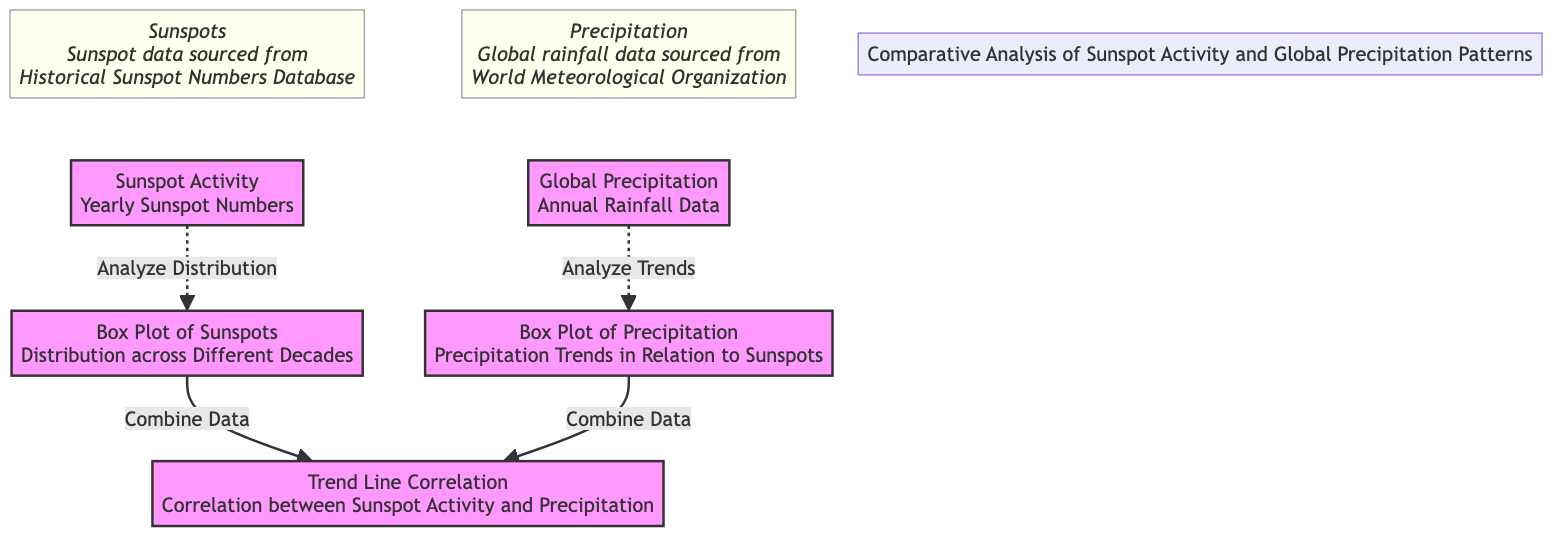What is the main subject of the diagram? The diagram focuses on the comparative analysis of sunspot activity and global precipitation patterns. It illustrates how sunspot activity relates to global rainfall trends over the years.
Answer: Comparative analysis of sunspot activity and global precipitation patterns How many main components are there in the diagram? The diagram consists of five main components: sunspot activity, global precipitation, box plot of sunspots, box plot of precipitation, and trend line correlation.
Answer: Five What is the relationship indicated between the box plots and trend line correlation? The box plots of both sunspot activity and global precipitation serve as inputs for the trend line correlation, implying that the correlation is derived from the data represented in both box plots.
Answer: Combine Data Which node provides the source for sunspot data? The diagram indicates that the sunspot data is sourced from the Historical Sunspot Numbers Database. This information is provided as an annotation associated with the sunspot activity node.
Answer: Historical Sunspot Numbers Database Why is global rainfall data sourced from the World Meteorological Organization? The World Meteorological Organization is a reliable and authoritative source for global precipitation data, providing consistent and standardized information crucial for analyzing precipitation trends in relation to sunspots.
Answer: Reliable source How does the trend line correlation connect to both box plots? The trend line correlation draws connections from both the box plot of sunspots and the box plot of precipitation, indicating that the final analysis integrates data from the distribution of sunspots and the trends in precipitation.
Answer: Indicates integration of both What type of analysis does the box plot of sunspots perform? The box plot of sunspots analyzes the distribution of yearly sunspot numbers across different decades, allowing for a visual representation of changes and variations over time.
Answer: Analyze Distribution What is the visual representation method used in the diagram for analyzing sunspot and precipitation data? The diagram utilizes box plots and trend lines as the primary methods for visually representing and analyzing the data related to sunspot activity and global precipitation patterns.
Answer: Box plots and trend lines 